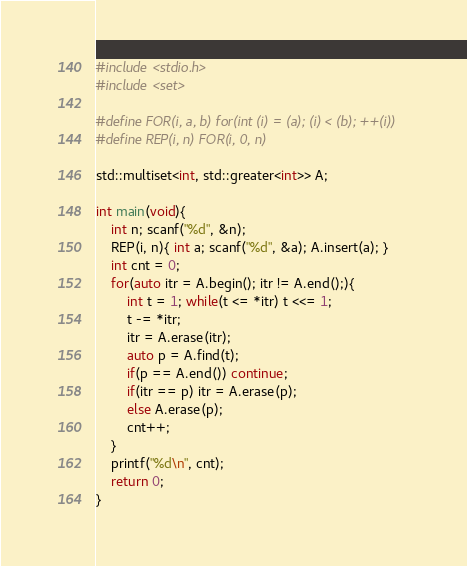<code> <loc_0><loc_0><loc_500><loc_500><_C++_>#include <stdio.h>
#include <set>

#define FOR(i, a, b) for(int (i) = (a); (i) < (b); ++(i))
#define REP(i, n) FOR(i, 0, n)

std::multiset<int, std::greater<int>> A;

int main(void){    
    int n; scanf("%d", &n);
    REP(i, n){ int a; scanf("%d", &a); A.insert(a); }
    int cnt = 0;
    for(auto itr = A.begin(); itr != A.end();){
        int t = 1; while(t <= *itr) t <<= 1;
        t -= *itr;
        itr = A.erase(itr);
        auto p = A.find(t);
        if(p == A.end()) continue;
        if(itr == p) itr = A.erase(p);
        else A.erase(p);
        cnt++;
    }
    printf("%d\n", cnt);
    return 0;
}</code> 